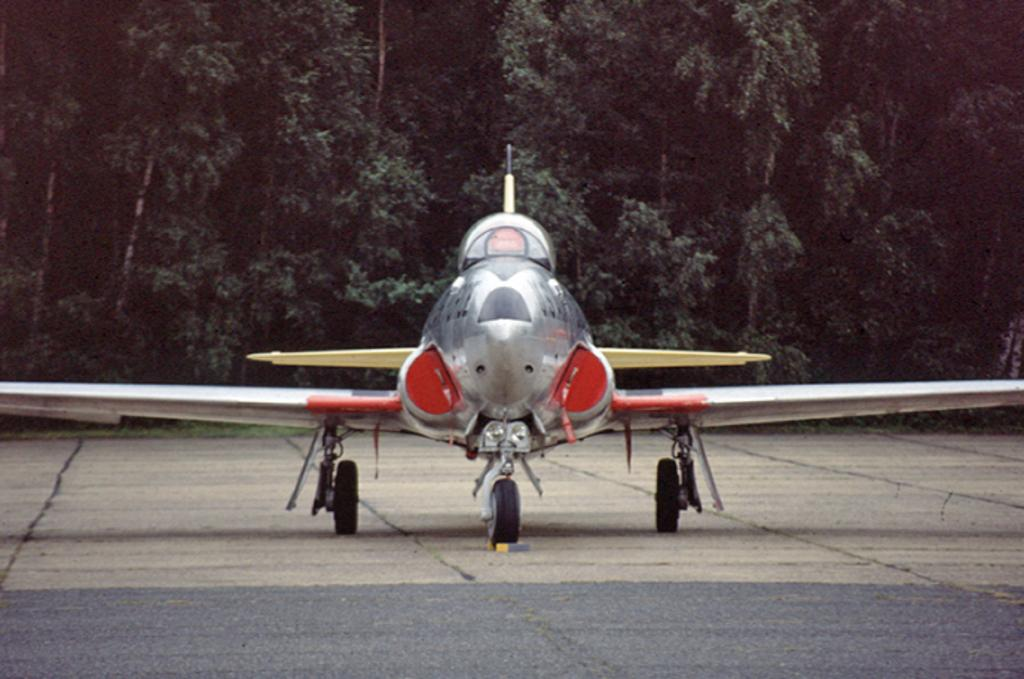What is the main subject of the image? The main subject of the image is an aircraft. Where is the aircraft located in the image? The aircraft is on the road in the image. What can be seen in the background of the image? There are trees in the background of the image. What type of fire can be seen burning near the aircraft in the image? There is no fire present in the image; it only features an aircraft on the road with trees in the background. 